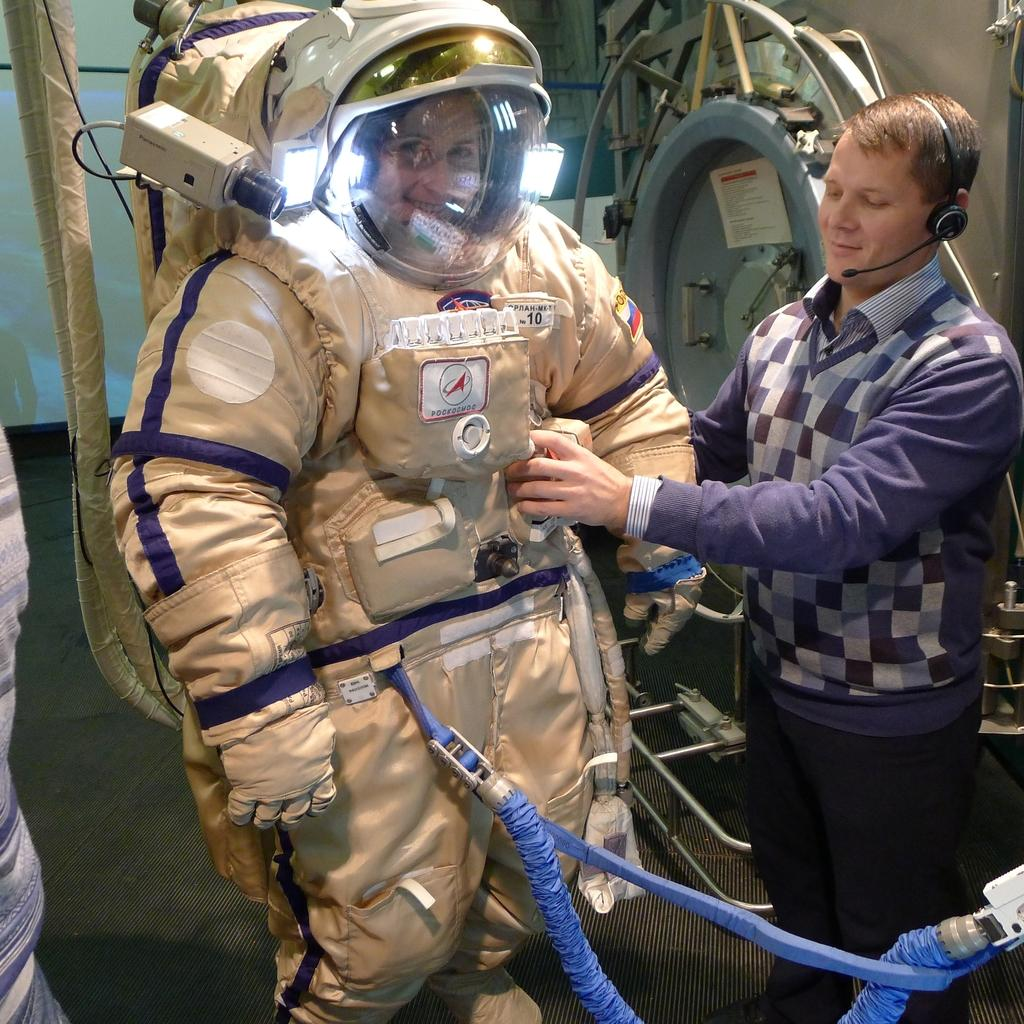Who is the main subject in the center of the image? There is an astronaut in the center of the image. Can you describe the other person in the image? There is another man standing on the right side of the image. What type of family event is happening in the image? There is no family event depicted in the image; it features an astronaut and another man. Can you see any roses in the image? There are no roses present in the image. 